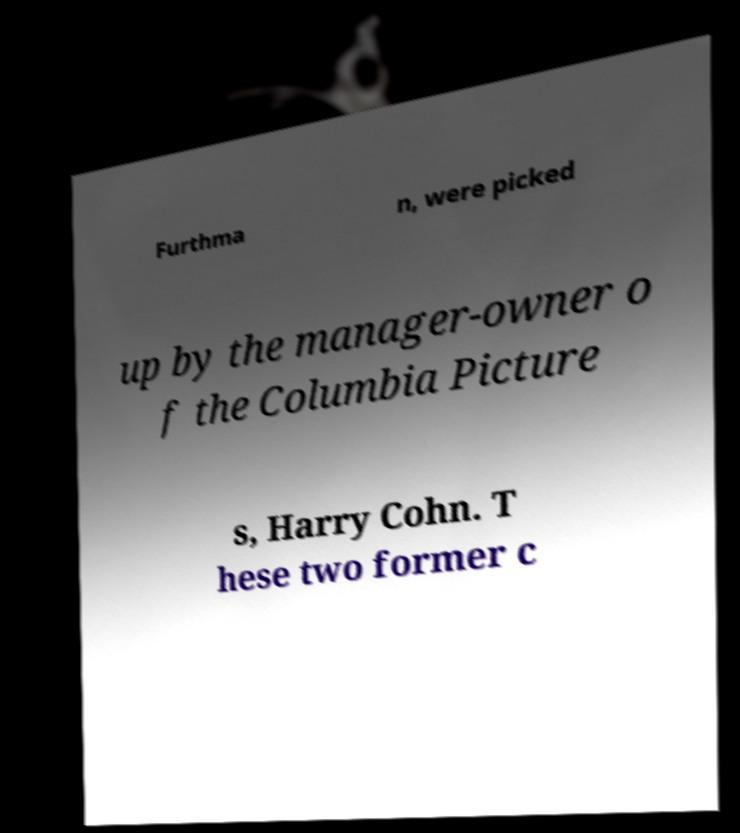Could you assist in decoding the text presented in this image and type it out clearly? Furthma n, were picked up by the manager-owner o f the Columbia Picture s, Harry Cohn. T hese two former c 